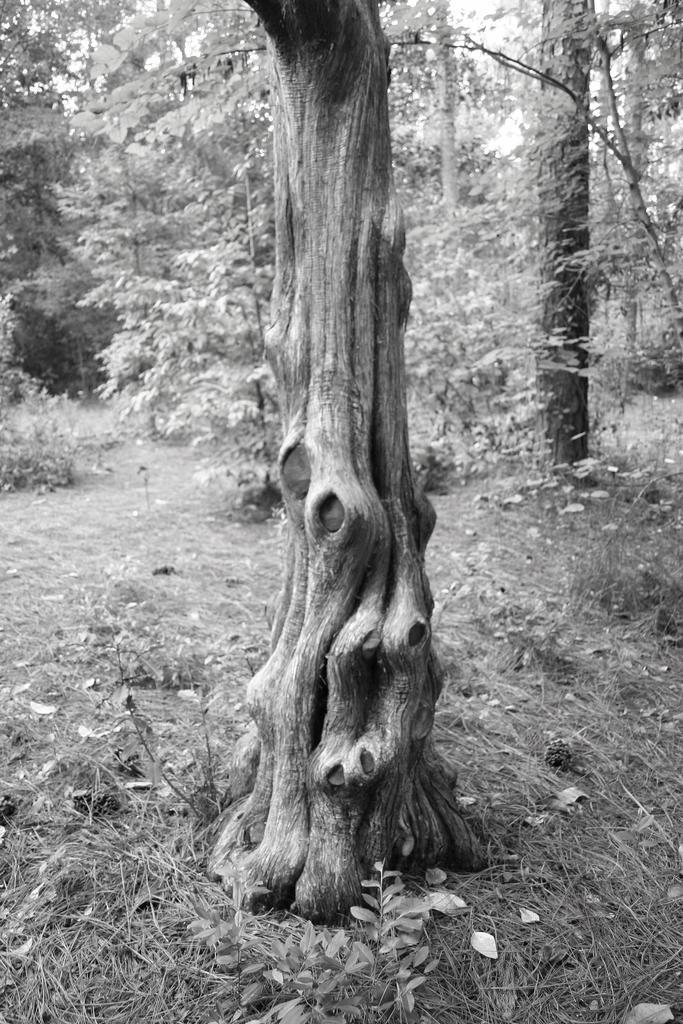How would you summarize this image in a sentence or two? This is a black and white image. I can see the tree trunk. I can see the grass and the trees with branches and leaves. 